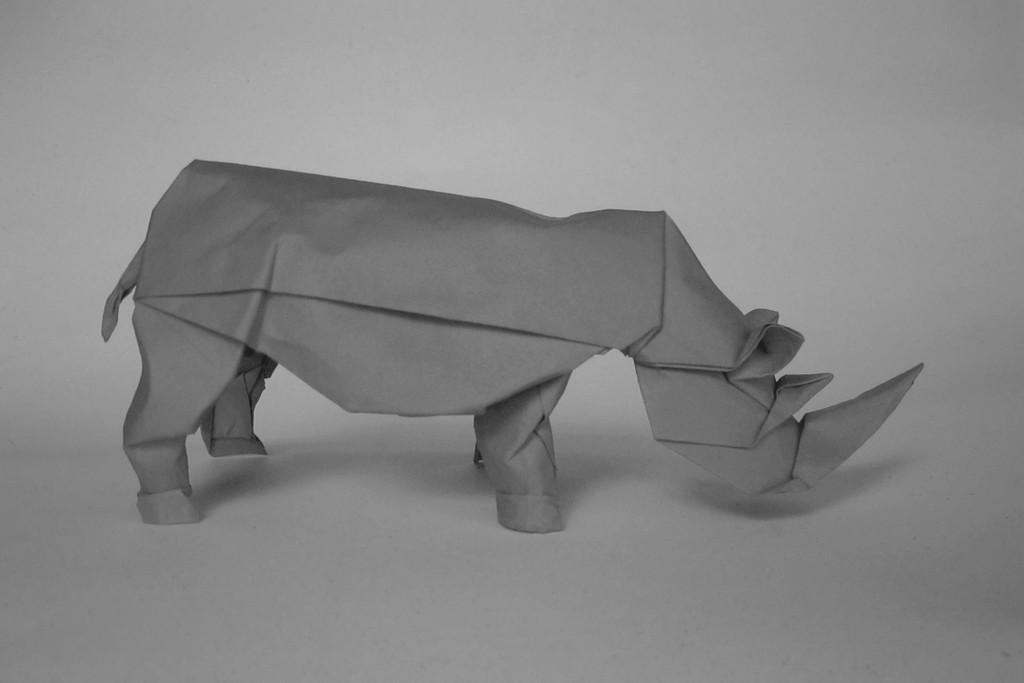What type of origami figure is in the picture? There is an origami rhinoceros in the picture. What is the origami rhinoceros placed on? The origami rhinoceros is on an object. What type of leaf is used to create the origami rhinoceros in the image? There is no leaf used to create the origami rhinoceros in the image; it is made of paper. 